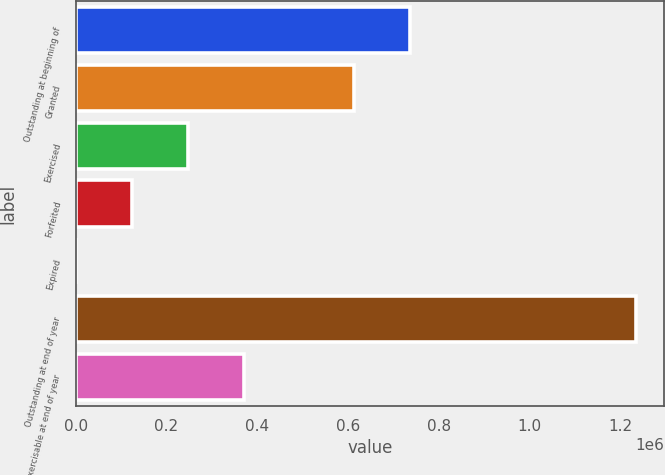<chart> <loc_0><loc_0><loc_500><loc_500><bar_chart><fcel>Outstanding at beginning of<fcel>Granted<fcel>Exercised<fcel>Forfeited<fcel>Expired<fcel>Outstanding at end of year<fcel>Exercisable at end of year<nl><fcel>736132<fcel>612681<fcel>247176<fcel>123724<fcel>273<fcel>1.23479e+06<fcel>370627<nl></chart> 